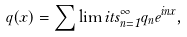Convert formula to latex. <formula><loc_0><loc_0><loc_500><loc_500>q ( x ) = { \sum \lim i t s _ { n = 1 } ^ { \infty } } q _ { n } e ^ { i n x } ,</formula> 